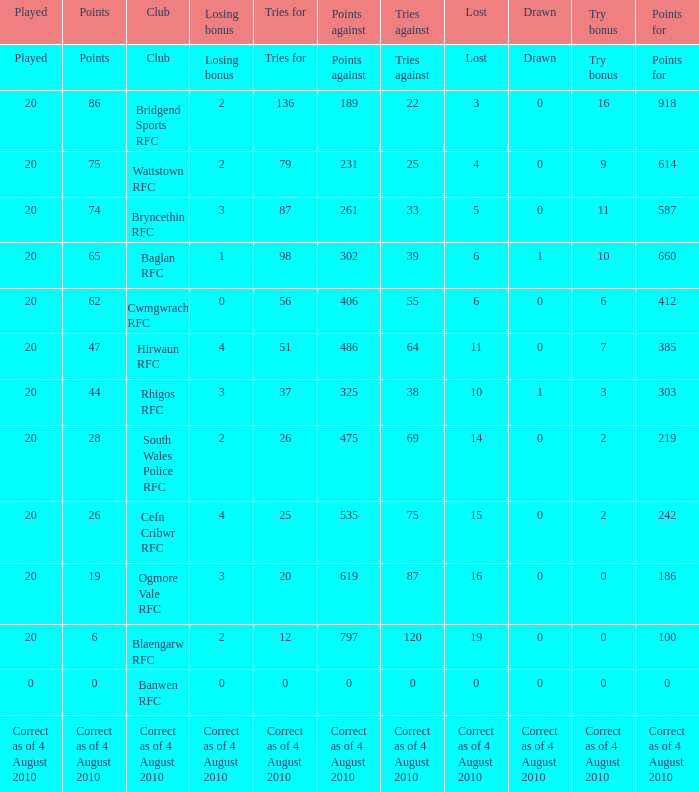What is the tries fow when losing bonus is losing bonus? Tries for. 